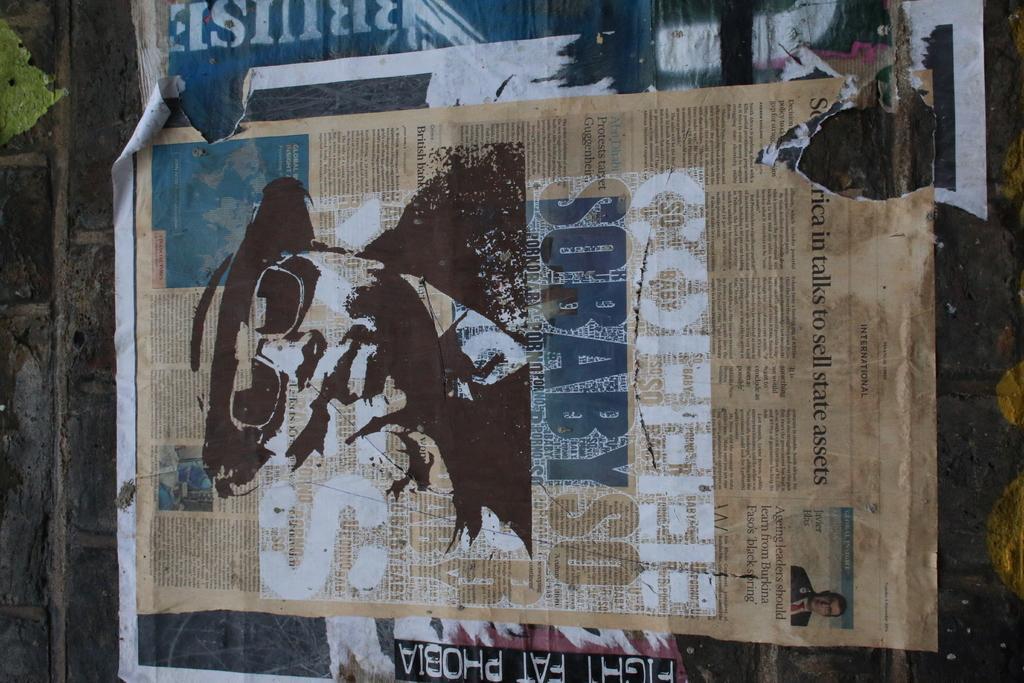Please provide a concise description of this image. This image consists of a poster, which is pasted on a wall. It looks like a newspaper. 